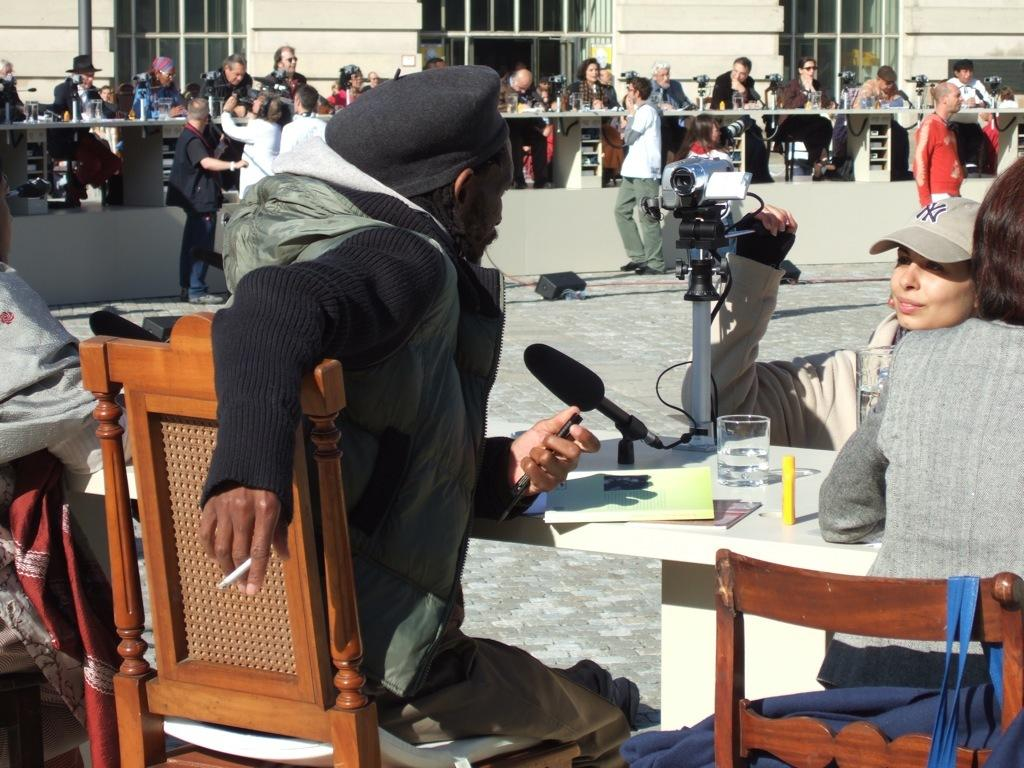Who or what can be seen in the image? There are people in the image. What are some of the people doing in the image? Some people are sitting on chairs. What equipment is visible in the image? There is a camera and a microphone in the image. What object can be seen on a table in the image? There is a glass on a table in the image. What type of wool is being used by the ghost in the image? There is no ghost or wool present in the image. Can you tell me what kind of field is visible in the image? There is no field visible in the image. 